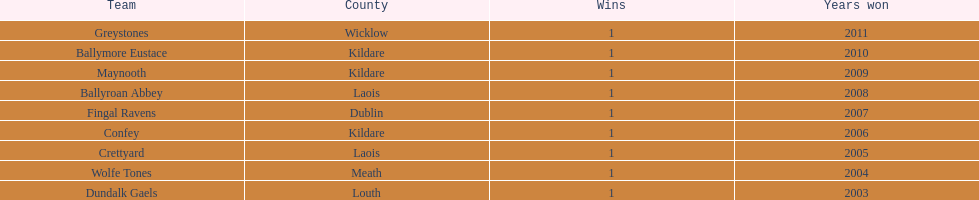Give me the full table as a dictionary. {'header': ['Team', 'County', 'Wins', 'Years won'], 'rows': [['Greystones', 'Wicklow', '1', '2011'], ['Ballymore Eustace', 'Kildare', '1', '2010'], ['Maynooth', 'Kildare', '1', '2009'], ['Ballyroan Abbey', 'Laois', '1', '2008'], ['Fingal Ravens', 'Dublin', '1', '2007'], ['Confey', 'Kildare', '1', '2006'], ['Crettyard', 'Laois', '1', '2005'], ['Wolfe Tones', 'Meath', '1', '2004'], ['Dundalk Gaels', 'Louth', '1', '2003']]} Can you identify the initial team presented in the chart? Greystones. 